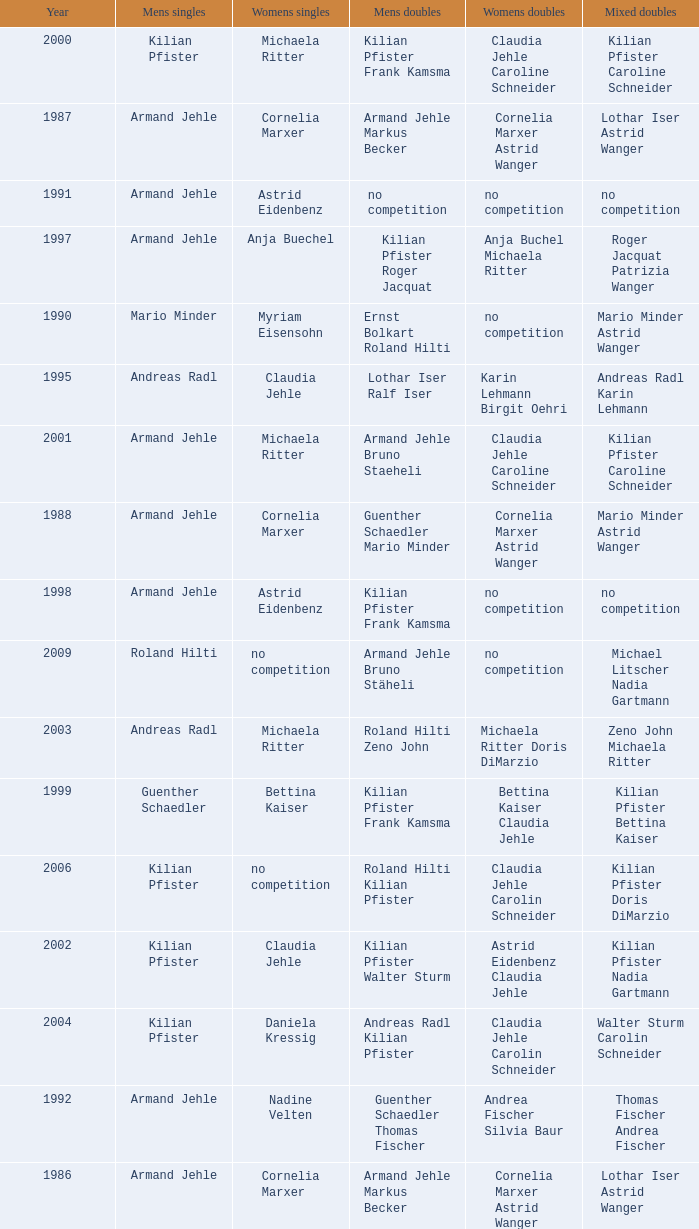In 2001, where the mens singles is armand jehle and the womens singles is michaela ritter, who are the mixed doubles Kilian Pfister Caroline Schneider. 